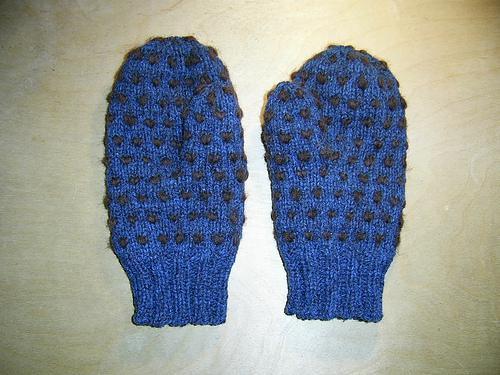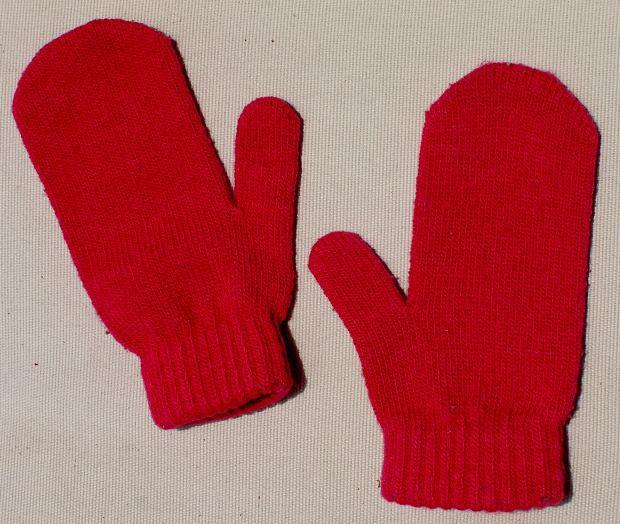The first image is the image on the left, the second image is the image on the right. For the images displayed, is the sentence "Images each show one pair of mittens, and the mitten pairs are the same length." factually correct? Answer yes or no. Yes. The first image is the image on the left, the second image is the image on the right. For the images displayed, is the sentence "The pair of gloves on the right is at least mostly red in color." factually correct? Answer yes or no. Yes. 